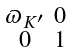<formula> <loc_0><loc_0><loc_500><loc_500>\begin{smallmatrix} \varpi _ { K ^ { \prime } } & 0 \\ 0 & 1 \end{smallmatrix}</formula> 